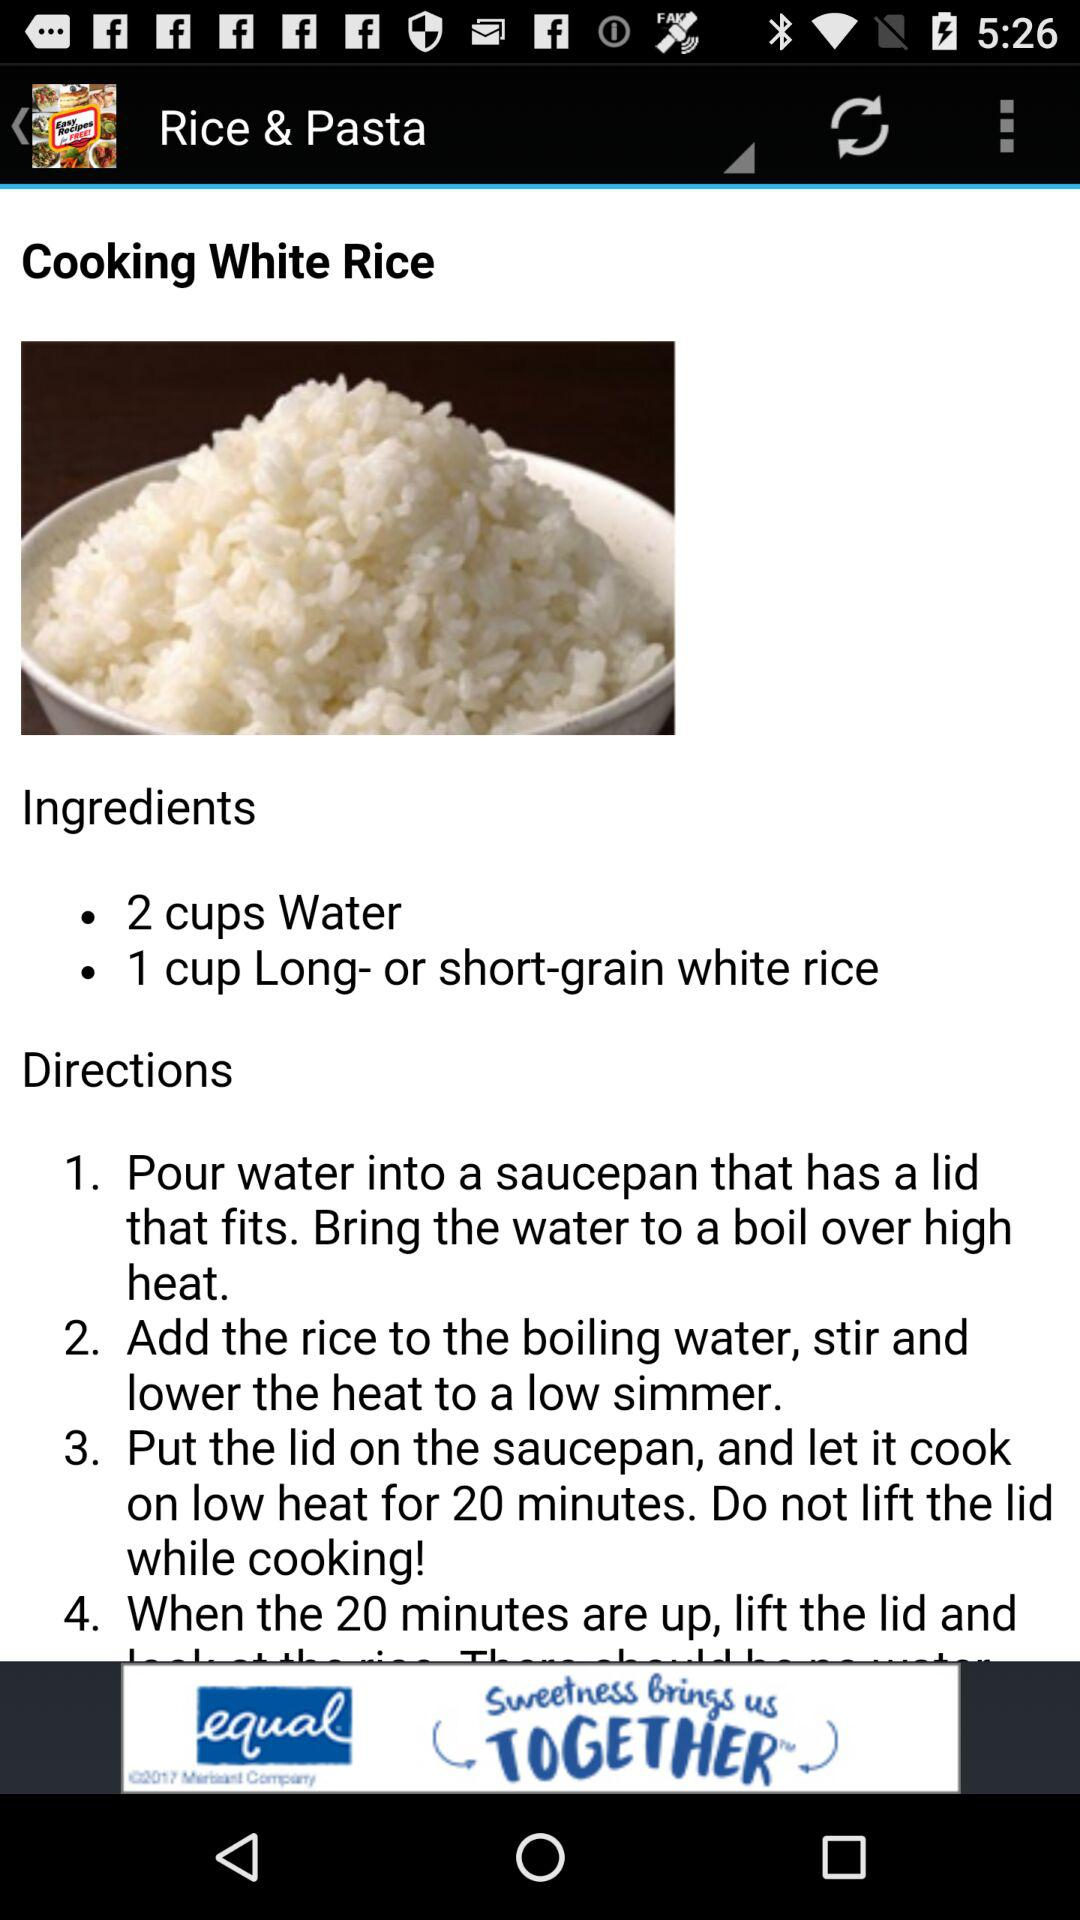How much water is used in the recipe? In the recipe, 2 cups of water are used. 